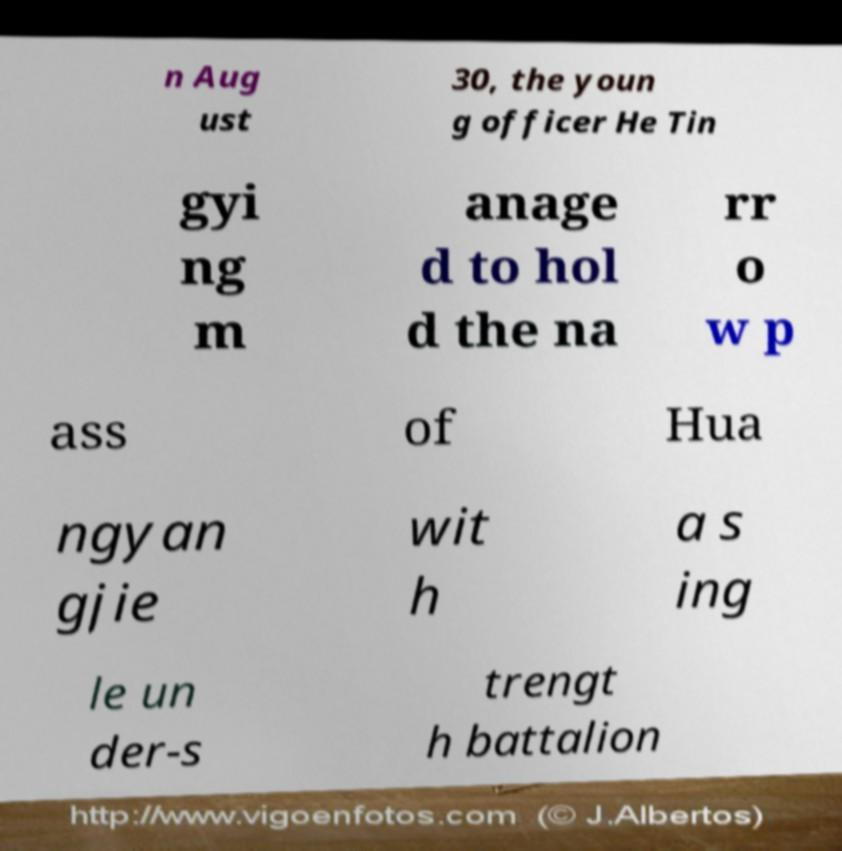Please identify and transcribe the text found in this image. n Aug ust 30, the youn g officer He Tin gyi ng m anage d to hol d the na rr o w p ass of Hua ngyan gjie wit h a s ing le un der-s trengt h battalion 